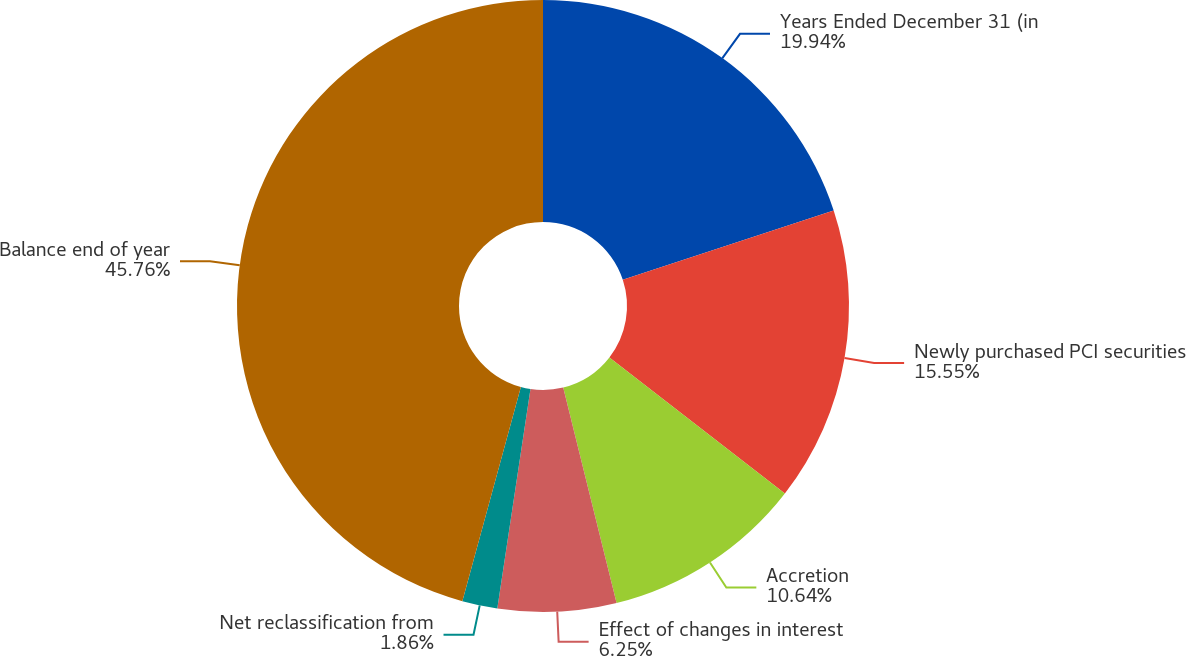Convert chart to OTSL. <chart><loc_0><loc_0><loc_500><loc_500><pie_chart><fcel>Years Ended December 31 (in<fcel>Newly purchased PCI securities<fcel>Accretion<fcel>Effect of changes in interest<fcel>Net reclassification from<fcel>Balance end of year<nl><fcel>19.94%<fcel>15.55%<fcel>10.64%<fcel>6.25%<fcel>1.86%<fcel>45.75%<nl></chart> 